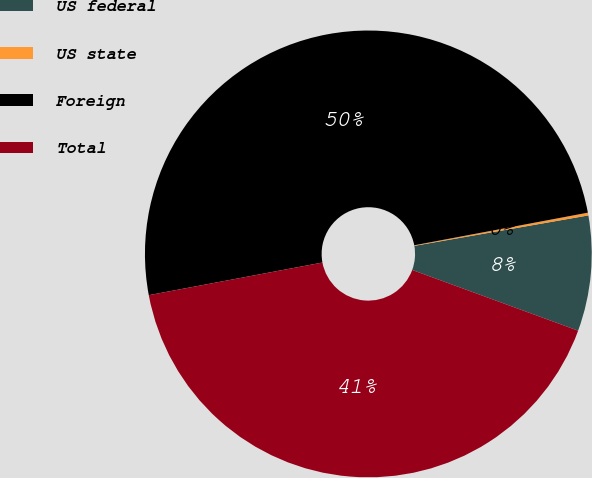<chart> <loc_0><loc_0><loc_500><loc_500><pie_chart><fcel>US federal<fcel>US state<fcel>Foreign<fcel>Total<nl><fcel>8.34%<fcel>0.2%<fcel>50.0%<fcel>41.46%<nl></chart> 